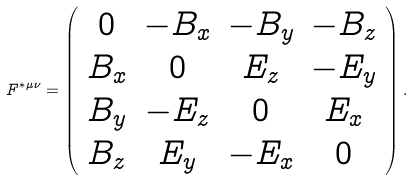<formula> <loc_0><loc_0><loc_500><loc_500>F ^ { * \mu \nu } = \left ( \begin{array} { c c c c } 0 & - B _ { x } & - B _ { y } & - B _ { z } \\ B _ { x } & 0 & E _ { z } & - E _ { y } \\ B _ { y } & - E _ { z } & 0 & E _ { x } \\ B _ { z } & E _ { y } & - E _ { x } & 0 \end{array} \right ) .</formula> 